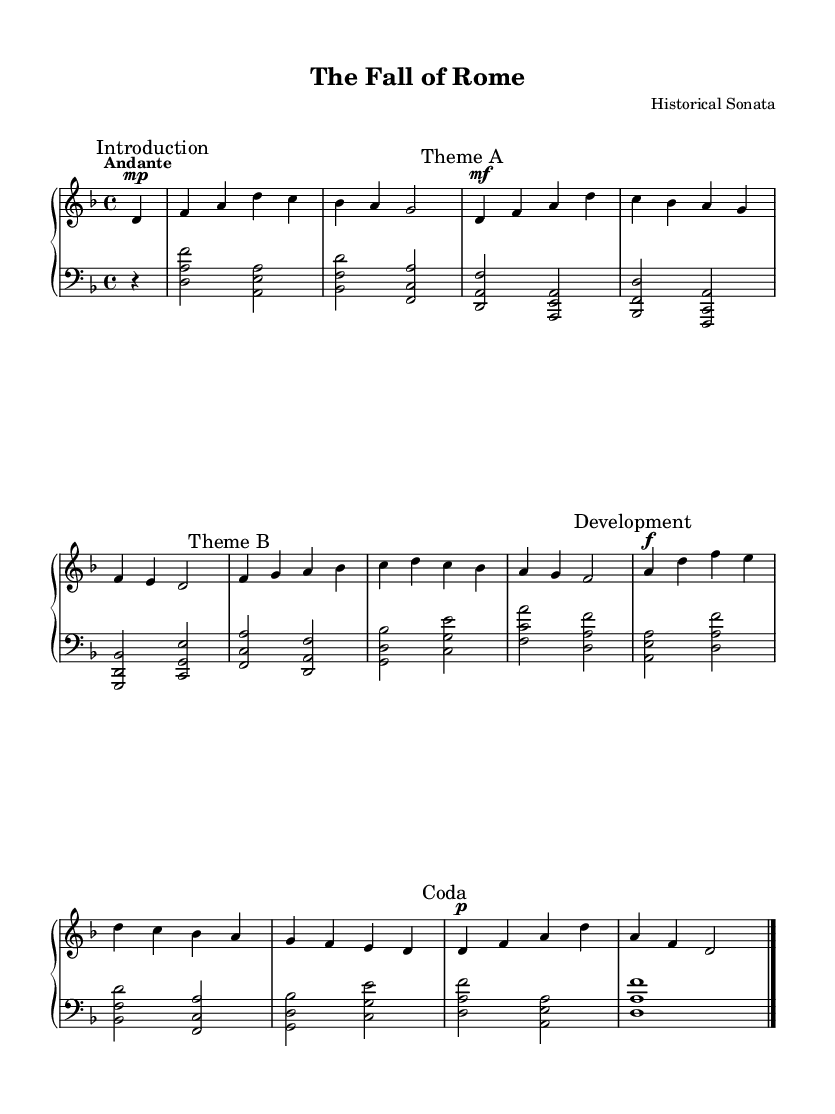What is the key signature of this music? The key signature is indicated at the beginning of the piece. It shows two flats (B♭ and E♭), which means it is in D minor.
Answer: D minor What is the time signature of this piece? The time signature is specified in the earlier section of the sheet music. It shows 4 beats in each measure, indicated by the "4/4" notation.
Answer: 4/4 What is the tempo marking of the piece? The tempo marking is provided just before the beginning of the music, which indicates the speed at which it should be played. It is marked as "Andante", suggesting a moderate pace.
Answer: Andante How many main themes are present in this piece? By analyzing the sections labeled in the sheet music, there are two distinct themes labeled as "Theme A" and "Theme B," which suggests there are two main themes.
Answer: 2 What dynamic indication is used for the "Development" section? The dynamic markings indicate how loudly or softly to play. In the "Development" section, it is marked with a "f," indicating it should be played loudly (forte).
Answer: f In which section is the "Coda" found? The "Coda" is found at the end of the piece, where it is explicitly marked. This section serves as a concluding part of the music.
Answer: At the end Which theme is presented first in the piece? By reviewing the order of the marked sections in the sheet music, "Theme A" is presented before "Theme B."
Answer: Theme A 